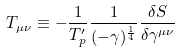Convert formula to latex. <formula><loc_0><loc_0><loc_500><loc_500>T _ { \mu \nu } \equiv - \frac { 1 } { T ^ { \prime } _ { p } } \frac { 1 } { ( - \gamma ) ^ { \frac { 1 } { 4 } } } \frac { \delta S } { \delta \gamma ^ { \mu \nu } }</formula> 